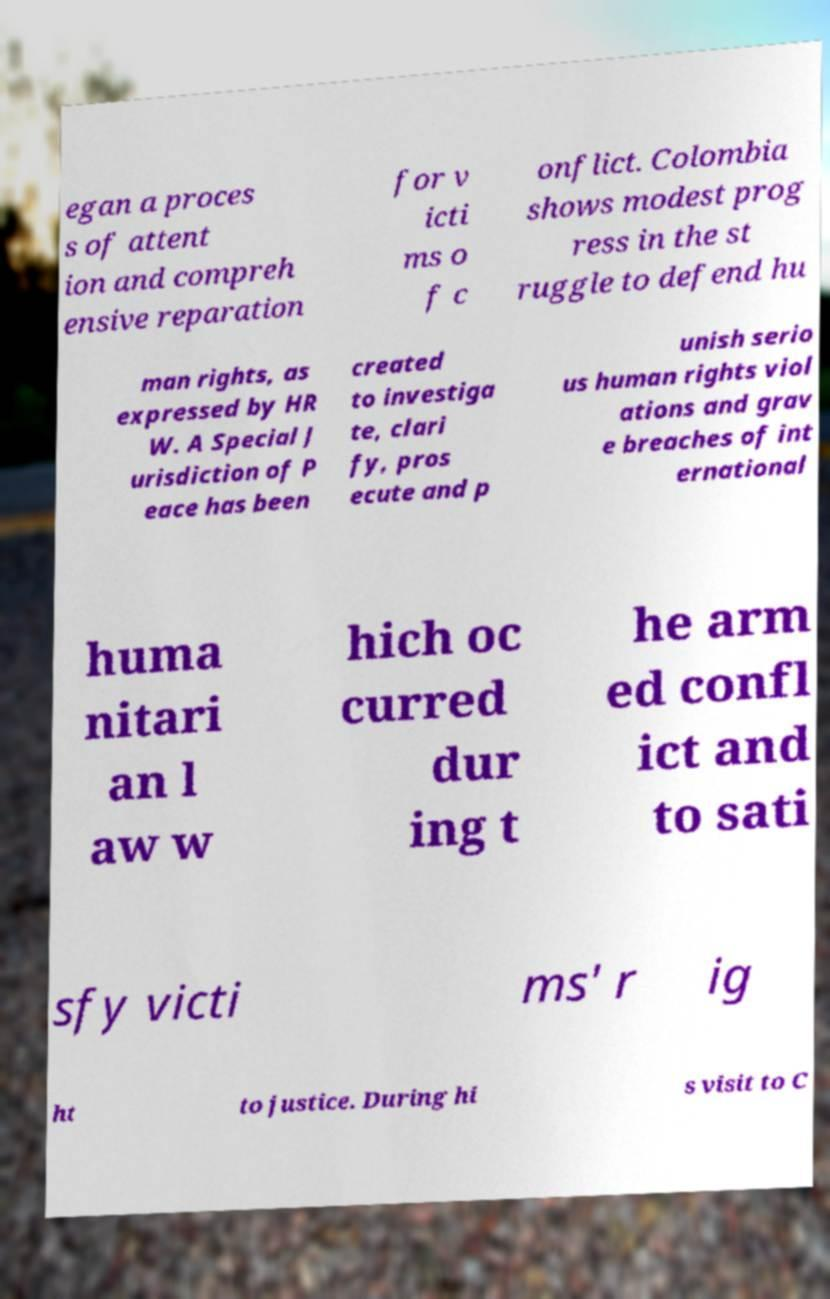Could you assist in decoding the text presented in this image and type it out clearly? egan a proces s of attent ion and compreh ensive reparation for v icti ms o f c onflict. Colombia shows modest prog ress in the st ruggle to defend hu man rights, as expressed by HR W. A Special J urisdiction of P eace has been created to investiga te, clari fy, pros ecute and p unish serio us human rights viol ations and grav e breaches of int ernational huma nitari an l aw w hich oc curred dur ing t he arm ed confl ict and to sati sfy victi ms' r ig ht to justice. During hi s visit to C 